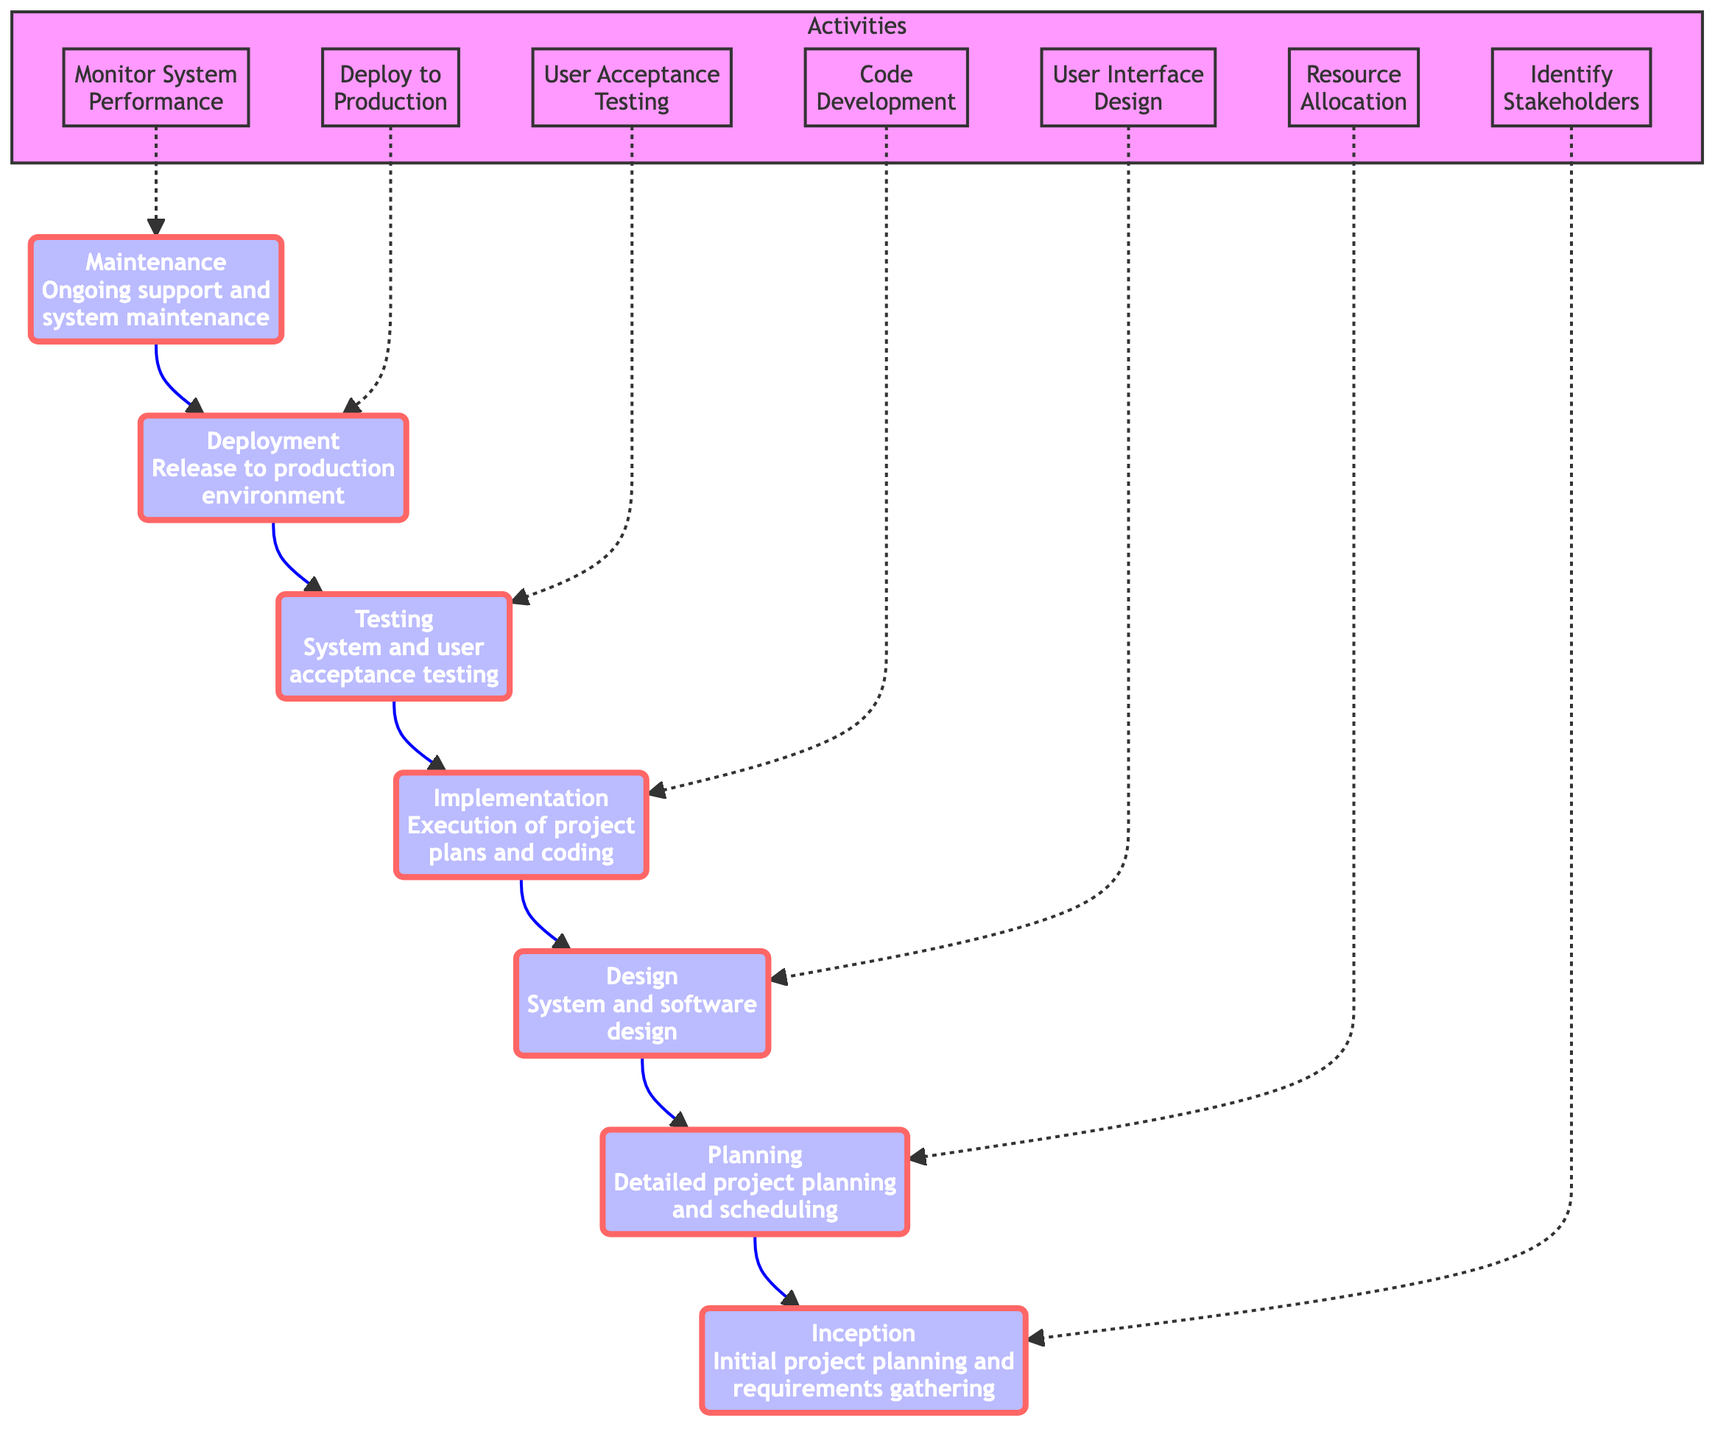What is the first stage of the IT project management process? The diagram indicates that the first stage is "Inception," which is the initial project planning and requirements gathering step in the entire process.
Answer: Inception How many main stages are there in the IT project flowchart? By counting each distinct stage in the flow, we identify a total of seven stages that are outlined in the diagram.
Answer: Seven What is the descriptive relationship between "Deployment" and "Tracing"? Looking at the flow from bottom to up, "Deployment" directly follows "Testing," indicating that Testing precedes Deployment in the project management process.
Answer: Testing What activities are associated with the "Maintenance" stage? The diagram lists specific activities related to "Maintenance," which include monitoring system performance, providing technical support, and implementing updates and enhancements.
Answer: Monitor System Performance, Provide Technical Support, Implement Updates and Enhancements Which stage follows "Implementation"? Upon checking the flow of the diagram upward, it states that the stage that comes after "Implementation" in the project management process is "Testing."
Answer: Testing What is the last stage before the end of the project flow? Following the flow from bottom to top, the last stage seen prior to "Maintenance" is "Deployment," which focuses on releasing the system to the production environment.
Answer: Deployment Which stage involves user interface design? By analyzing the stage contents, "Design" includes user interface design among other activities as detailed in the diagram.
Answer: Design What is the primary focus of the "Planning" stage? According to the description in the diagram, "Planning" involves detailed project planning and scheduling to ensure organized execution of the project.
Answer: Detailed project planning and scheduling What do you do after “User Acceptance Testing”? The diagram shows that after "User Acceptance Testing" within the context of "Testing," the flow leads to "Deployment," where the system is released into production.
Answer: Deployment 